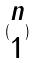<formula> <loc_0><loc_0><loc_500><loc_500>( \begin{matrix} n \\ 1 \end{matrix} )</formula> 